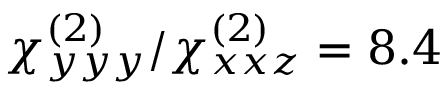<formula> <loc_0><loc_0><loc_500><loc_500>\chi _ { y y y } ^ { ( 2 ) } / \chi _ { x x z } ^ { ( 2 ) } = 8 . 4</formula> 